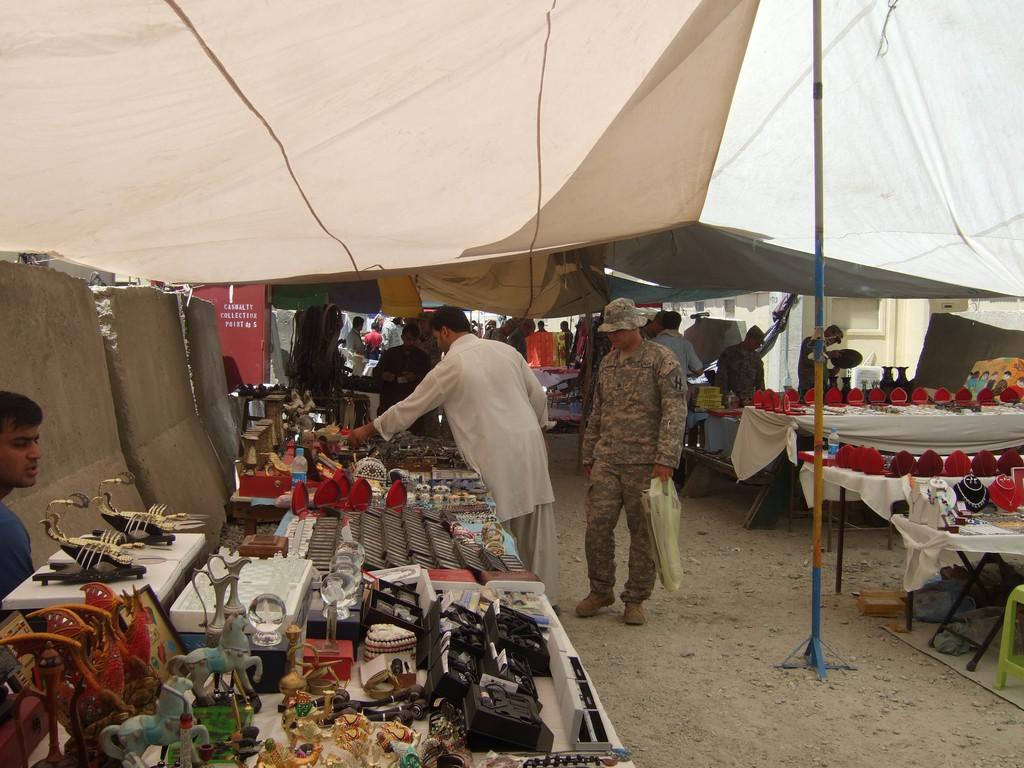Who or what can be seen in the image? There are people in the image. What type of structures are present in the image? There are stalls in the image. What are the objects on the tables used for? Objects are arranged on tables in the image, but their specific use is not mentioned. What is located on the left side of the image? There is a cement structure on the left side of the image. What theory is being discussed by the people in the image? There is no indication in the image that a theory is being discussed; the people's actions or conversations are not mentioned. What type of jam is being sold at the stalls in the image? There is no mention of jam or any food items being sold at the stalls in the image. 